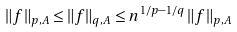Convert formula to latex. <formula><loc_0><loc_0><loc_500><loc_500>\| f \| _ { p , A } \leq \| f \| _ { q , A } \leq n ^ { 1 / p - 1 / q } \, \| f \| _ { p , A }</formula> 